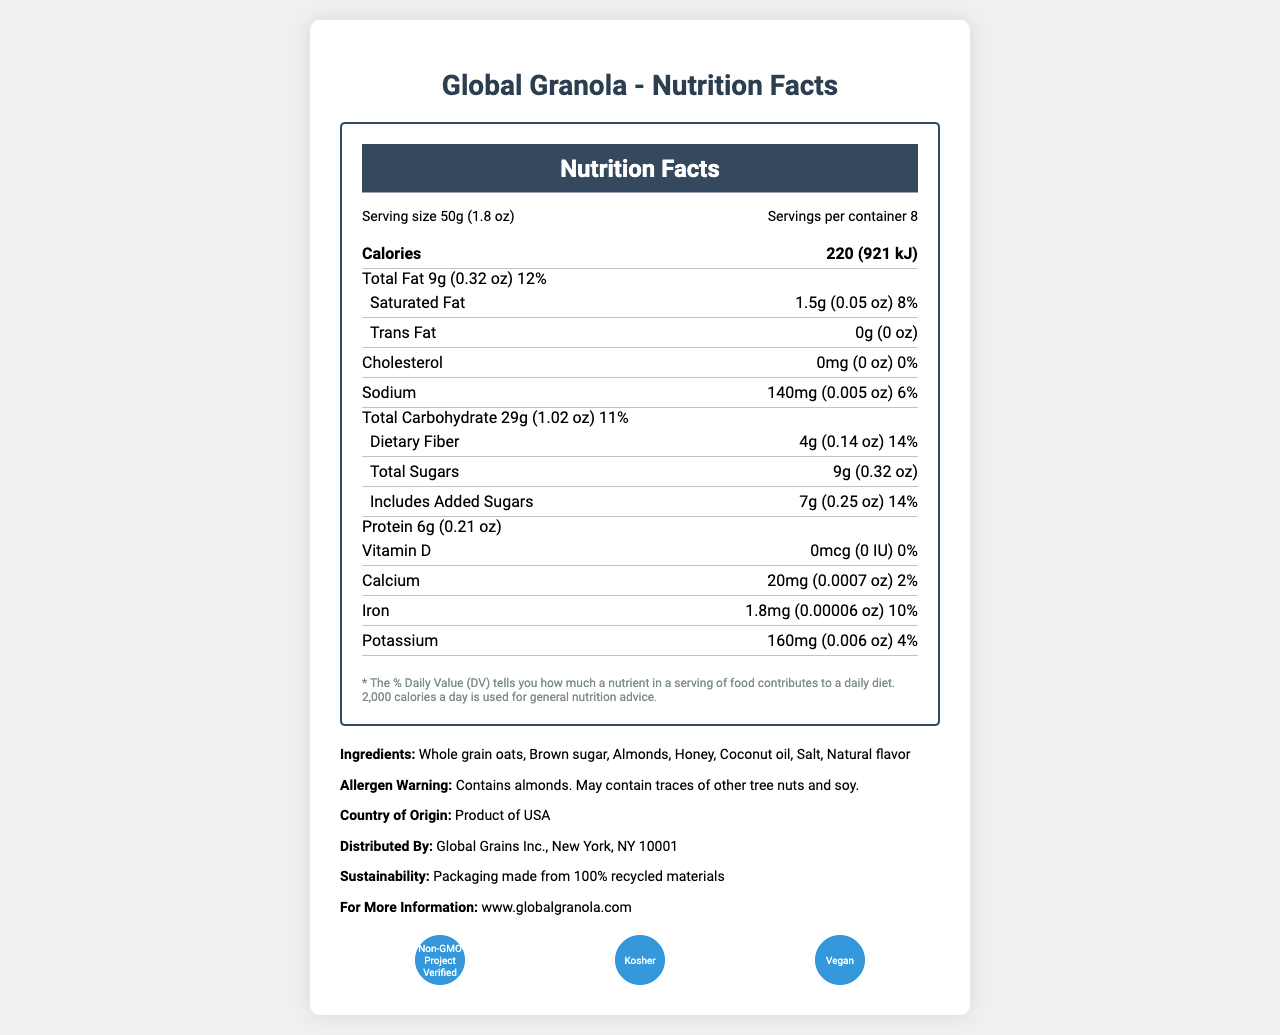what is the product name? The product name is displayed at the top of the document.
Answer: Global Granola what is the serving size in metric units? The serving size in metric units is listed as 50g in the 'Serving size' section.
Answer: 50g how many servings are there per container? The document states there are 8 servings per container in the 'Serving size' section.
Answer: 8 what are the total calories per serving? The 'Calories' section notes 220 kcal (921 kJ) per serving.
Answer: 220 kcal (921 kJ) which nutrient has the highest daily value percentage? The nutrient with the highest daily value percentage is Dietary Fiber at 14%.
Answer: Dietary Fiber (14%) how much Total Fat is there per serving in imperial units? The 'Total Fat' row indicates 0.32 oz per serving.
Answer: 0.32 oz What are the main ingredients in Global Granola? The main ingredients are listed in the 'Ingredients' section.
Answer: Whole grain oats, Brown sugar, Almonds, Honey, Coconut oil, Salt, Natural flavor is the product Non-GMO? One of the certifications listed is 'Non-GMO Project Verified', indicating the product is Non-GMO.
Answer: Yes which of the following vitamins and minerals is not present in any amount? A. Vitamin D B. Calcium C. Iron D. Potassium The document shows 0 mcg (0 IU) for Vitamin D, indicating it is not present.
Answer: A. Vitamin D how many grams of Added Sugars are included per serving? The 'Includes Added Sugars' row states there are 7g of Added Sugars per serving.
Answer: 7g is the product suitable for vegans? The 'Vegan' certification indicates the product is suitable for vegans.
Answer: Yes which of the following nutrient amounts is not provided in the document? A. Protein B. Trans Fat C. Polyunsaturated Fat D. Total Sugars The amounts for Polyunsaturated Fat are not mentioned in the document.
Answer: C. Polyunsaturated Fat which language options are available for the daily value disclaimer? A. English and Spanish B. English, Spanish, and French C. Spanish D. French and Spanish The daily value disclaimer is available in English, Spanish, and French.
Answer: B. English, Spanish, and French does the product contain almonds? The allergen warning states that the product contains almonds.
Answer: Yes summarize the main information covered in the document. The document provides comprehensive nutritional information about 'Global Granola', including servings, nutrient amounts, daily values, ingredients, certifications, and additional company details.
Answer: The document is a Nutrition Facts Label for 'Global Granola'. It includes detailed nutrient information in both metric and imperial units, serving size, calories, and daily value percentages. The label also lists ingredients, allergen warnings, certifications, and additional company and sustainability information. what is the distributor's company name? The distributor's company name is listed as 'Global Grains Inc.' in the 'Distributed By' section.
Answer: Global Grains Inc. which nutrient(s) contain 0 grams per serving? Trans Fat and Cholesterol are listed as 0 grams per serving in the document, and Vitamin D is also shown as 0 mcg.
Answer: Trans Fat, Cholesterol, Vitamin D what are the total carbohydrate and protein contents per serving in imperial units? A. 1.8 oz and 0.25 oz B. 1.02 oz and 0.32 oz C. 1.02 oz and 0.21 oz D. 0.32 oz and 0.21 oz Total Carbohydrate is listed as 1.02 oz and Protein is 0.21 oz per serving.
Answer: C. 1.02 oz and 0.21 oz how many certifications does the product have? The document lists three certifications: 'Non-GMO Project Verified', 'Kosher', and 'Vegan'.
Answer: 3 what is the daily value percentage for sodium? The daily value percentage for Sodium is listed as 6% in the nutrient section.
Answer: 6% what is the sustainability information mentioned for the packaging? The sustainability information indicates that the packaging is made from 100% recycled materials.
Answer: Packaging made from 100% recycled materials is the amount of Vitamin D provided in IU? The amount is provided in IU but indicates 0 IU, meaning there is no Vitamin D present.
Answer: Yes, but it is 0 IU are there any traces of soy mentioned in the allergen warning? The allergen warning mentions that the product may contain traces of soy.
Answer: Yes what are the metric and imperial amounts for calcium per serving? A. 20mg and 0.0007 oz B. 25mg and 0.001 oz C. 15mg and 0.0005 oz D. 10mg and 0.0002 oz The metric amount for calcium per serving is 20mg, which converts to 0.0007 oz in imperial units.
Answer: A. 20mg and 0.0007 oz what is the URL for more information? The URL for more information is provided as 'www.globalgranola.com'.
Answer: www.globalgranola.com are all the ingredients organic? The document does not provide information about whether the ingredients are organic.
Answer: Cannot be determined 